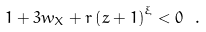Convert formula to latex. <formula><loc_0><loc_0><loc_500><loc_500>1 + 3 w _ { X } + r \left ( z + 1 \right ) ^ { \xi } < 0 \ .</formula> 